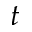<formula> <loc_0><loc_0><loc_500><loc_500>t</formula> 